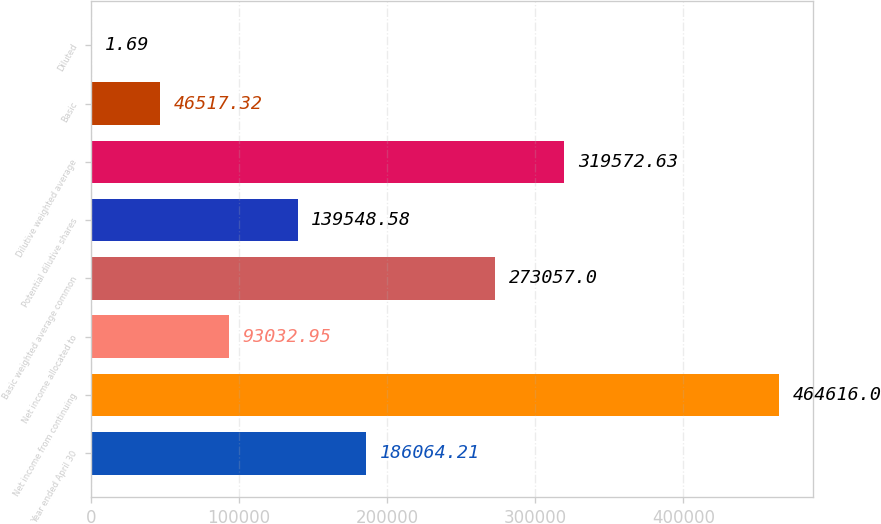<chart> <loc_0><loc_0><loc_500><loc_500><bar_chart><fcel>Year ended April 30<fcel>Net income from continuing<fcel>Net income allocated to<fcel>Basic weighted average common<fcel>Potential dilutive shares<fcel>Dilutive weighted average<fcel>Basic<fcel>Diluted<nl><fcel>186064<fcel>464616<fcel>93032.9<fcel>273057<fcel>139549<fcel>319573<fcel>46517.3<fcel>1.69<nl></chart> 